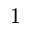Convert formula to latex. <formula><loc_0><loc_0><loc_500><loc_500>^ { 1 }</formula> 